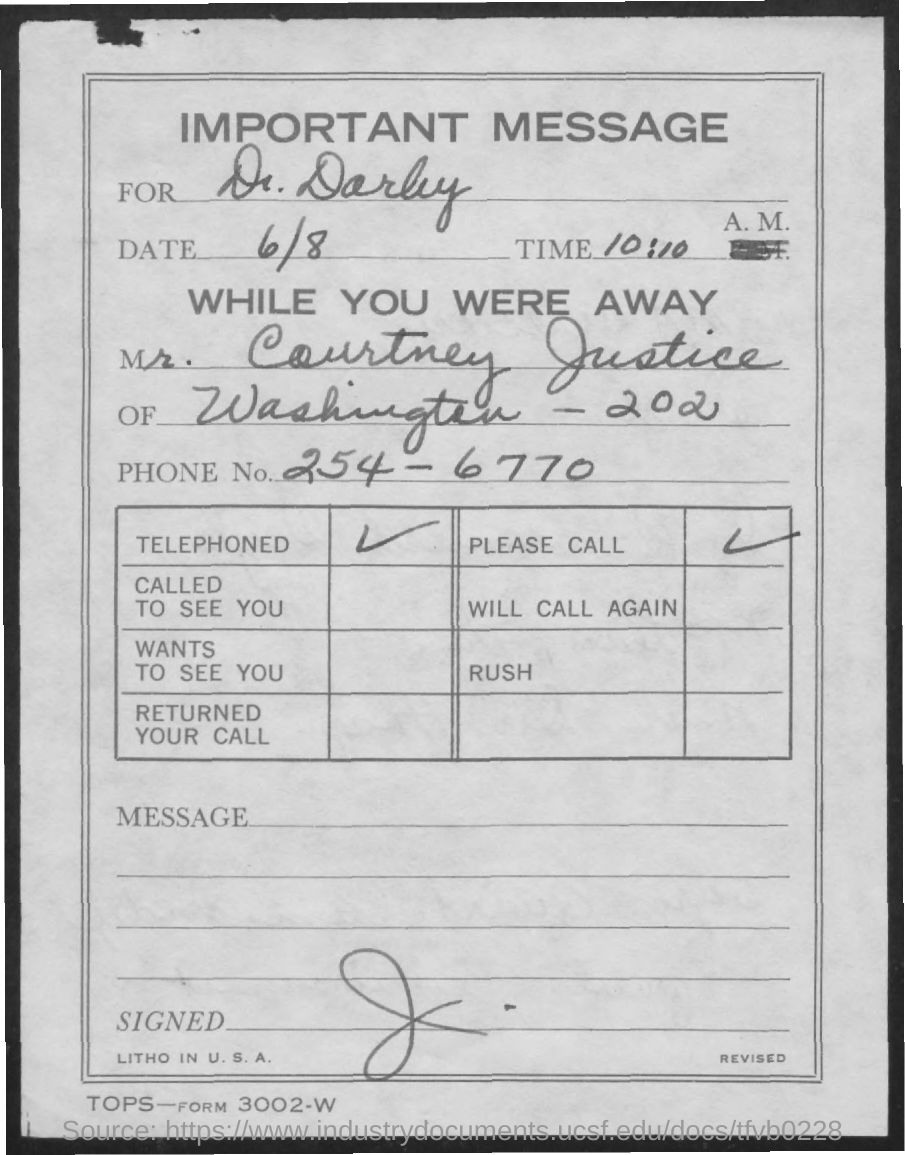To whom, the message is being sent?
Provide a succinct answer. Dr. Darby. What is the date mentioned in this document?
Your answer should be compact. 6/8. What is the phone No of Mr. Courtney Justice?
Offer a terse response. 254-6770. 